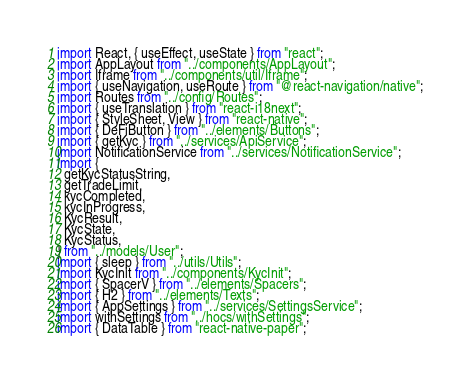<code> <loc_0><loc_0><loc_500><loc_500><_TypeScript_>import React, { useEffect, useState } from "react";
import AppLayout from "../components/AppLayout";
import Iframe from "../components/util/Iframe";
import { useNavigation, useRoute } from "@react-navigation/native";
import Routes from "../config/Routes";
import { useTranslation } from "react-i18next";
import { StyleSheet, View } from "react-native";
import { DeFiButton } from "../elements/Buttons";
import { getKyc } from "../services/ApiService";
import NotificationService from "../services/NotificationService";
import {
  getKycStatusString,
  getTradeLimit,
  kycCompleted,
  kycInProgress,
  KycResult,
  KycState,
  KycStatus,
} from "../models/User";
import { sleep } from "../utils/Utils";
import KycInit from "../components/KycInit";
import { SpacerV } from "../elements/Spacers";
import { H2 } from "../elements/Texts";
import { AppSettings } from "../services/SettingsService";
import withSettings from "../hocs/withSettings";
import { DataTable } from "react-native-paper";</code> 